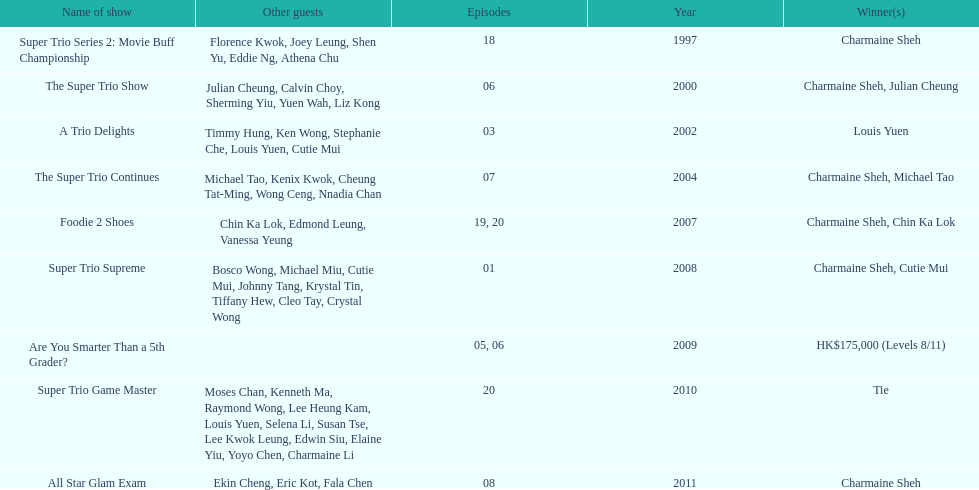How long has it been since chermaine sheh first appeared on a variety show? 17 years. 